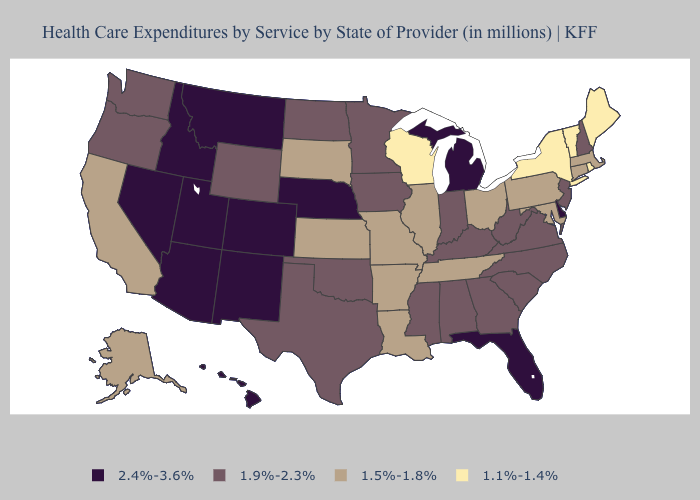What is the highest value in states that border Montana?
Give a very brief answer. 2.4%-3.6%. Name the states that have a value in the range 2.4%-3.6%?
Give a very brief answer. Arizona, Colorado, Delaware, Florida, Hawaii, Idaho, Michigan, Montana, Nebraska, Nevada, New Mexico, Utah. Which states hav the highest value in the Northeast?
Quick response, please. New Hampshire, New Jersey. What is the highest value in the USA?
Keep it brief. 2.4%-3.6%. What is the value of Ohio?
Be succinct. 1.5%-1.8%. Name the states that have a value in the range 1.1%-1.4%?
Keep it brief. Maine, New York, Rhode Island, Vermont, Wisconsin. Which states have the lowest value in the USA?
Answer briefly. Maine, New York, Rhode Island, Vermont, Wisconsin. What is the lowest value in the West?
Be succinct. 1.5%-1.8%. Which states have the lowest value in the MidWest?
Be succinct. Wisconsin. Among the states that border Georgia , which have the highest value?
Concise answer only. Florida. Among the states that border Iowa , does Nebraska have the highest value?
Concise answer only. Yes. What is the value of West Virginia?
Write a very short answer. 1.9%-2.3%. Is the legend a continuous bar?
Write a very short answer. No. Name the states that have a value in the range 1.5%-1.8%?
Be succinct. Alaska, Arkansas, California, Connecticut, Illinois, Kansas, Louisiana, Maryland, Massachusetts, Missouri, Ohio, Pennsylvania, South Dakota, Tennessee. Name the states that have a value in the range 1.5%-1.8%?
Be succinct. Alaska, Arkansas, California, Connecticut, Illinois, Kansas, Louisiana, Maryland, Massachusetts, Missouri, Ohio, Pennsylvania, South Dakota, Tennessee. 